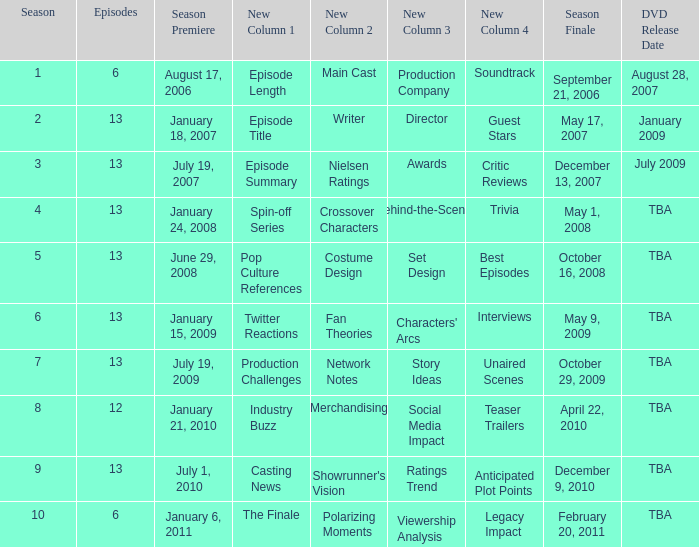On what date was the DVD released for the season with fewer than 13 episodes that aired before season 8? August 28, 2007. 